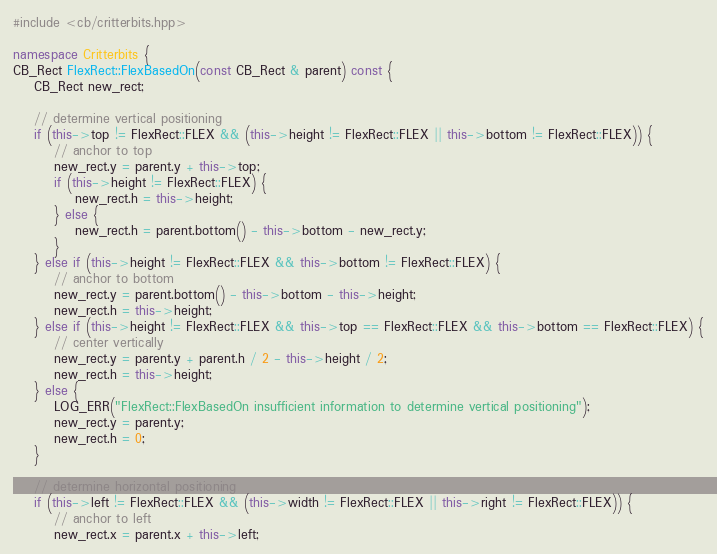Convert code to text. <code><loc_0><loc_0><loc_500><loc_500><_C++_>#include <cb/critterbits.hpp>

namespace Critterbits {
CB_Rect FlexRect::FlexBasedOn(const CB_Rect & parent) const {
    CB_Rect new_rect;

    // determine vertical positioning
    if (this->top != FlexRect::FLEX && (this->height != FlexRect::FLEX || this->bottom != FlexRect::FLEX)) {
        // anchor to top
        new_rect.y = parent.y + this->top;
        if (this->height != FlexRect::FLEX) {
            new_rect.h = this->height;
        } else {
            new_rect.h = parent.bottom() - this->bottom - new_rect.y;
        }
    } else if (this->height != FlexRect::FLEX && this->bottom != FlexRect::FLEX) {
        // anchor to bottom
        new_rect.y = parent.bottom() - this->bottom - this->height;
        new_rect.h = this->height;
    } else if (this->height != FlexRect::FLEX && this->top == FlexRect::FLEX && this->bottom == FlexRect::FLEX) {
        // center vertically
        new_rect.y = parent.y + parent.h / 2 - this->height / 2;
        new_rect.h = this->height; 
    } else {
        LOG_ERR("FlexRect::FlexBasedOn insufficient information to determine vertical positioning");
        new_rect.y = parent.y;
        new_rect.h = 0;
    }

    // determine horizontal positioning
    if (this->left != FlexRect::FLEX && (this->width != FlexRect::FLEX || this->right != FlexRect::FLEX)) {
        // anchor to left
        new_rect.x = parent.x + this->left;</code> 